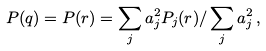<formula> <loc_0><loc_0><loc_500><loc_500>P ( { q } ) = P ( { r } ) = \sum _ { j } a ^ { 2 } _ { j } P _ { j } ( { r } ) / \sum _ { j } a _ { j } ^ { 2 } \, ,</formula> 